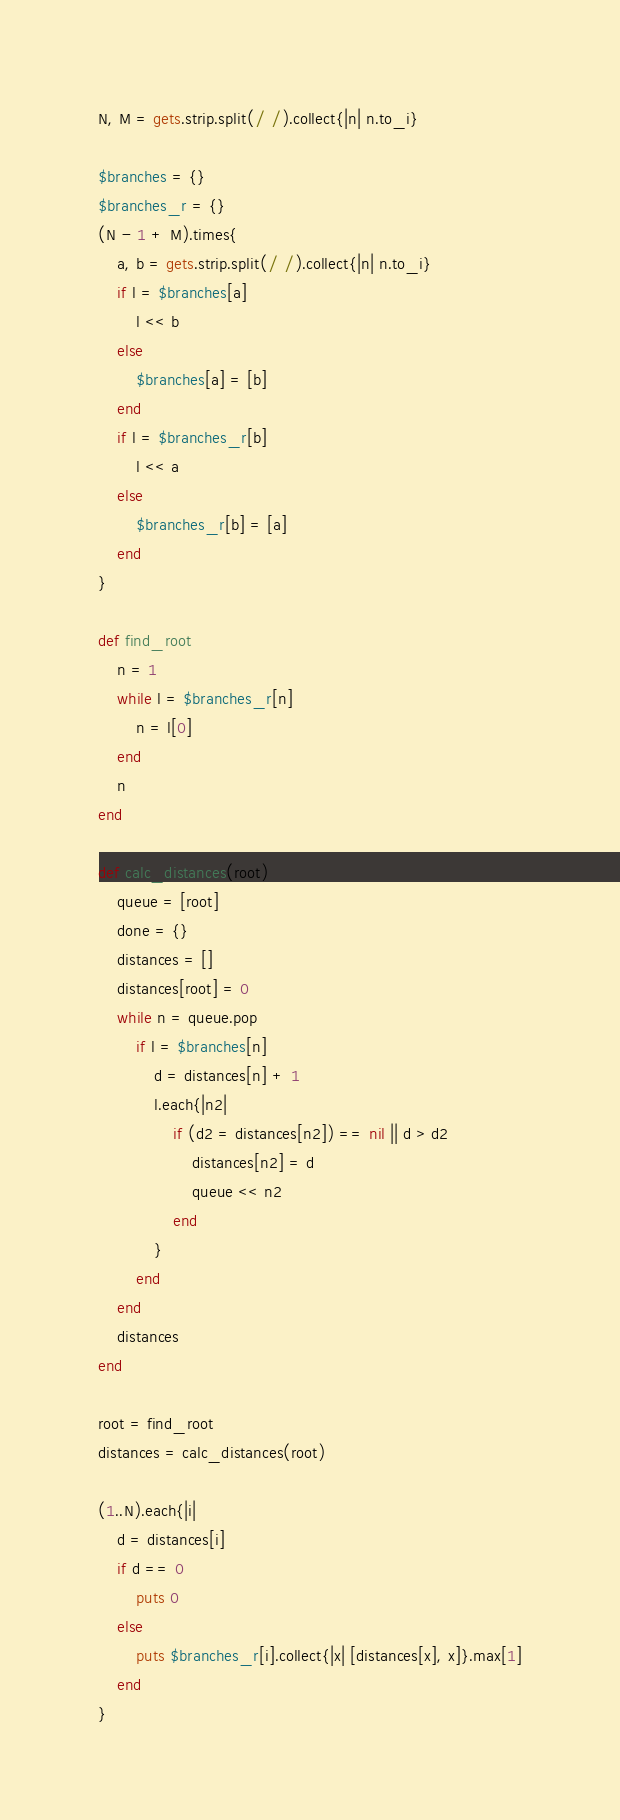<code> <loc_0><loc_0><loc_500><loc_500><_Ruby_>N, M = gets.strip.split(/ /).collect{|n| n.to_i}

$branches = {}
$branches_r = {}
(N - 1 + M).times{
	a, b = gets.strip.split(/ /).collect{|n| n.to_i}
	if l = $branches[a]
		l << b
	else
		$branches[a] = [b]
	end
	if l = $branches_r[b]
		l << a
	else
		$branches_r[b] = [a]
	end
}

def find_root
	n = 1
	while l = $branches_r[n]
		n = l[0]
	end
	n
end

def calc_distances(root)
	queue = [root]
	done = {}
	distances = []
	distances[root] = 0
	while n = queue.pop
		if l = $branches[n]
			d = distances[n] + 1
			l.each{|n2|
				if (d2 = distances[n2]) == nil || d > d2
					distances[n2] = d
					queue << n2
				end
			}
		end
	end
	distances
end

root = find_root
distances = calc_distances(root)

(1..N).each{|i|
	d = distances[i]
	if d == 0
		puts 0
	else
		puts $branches_r[i].collect{|x| [distances[x], x]}.max[1]
	end
}

</code> 